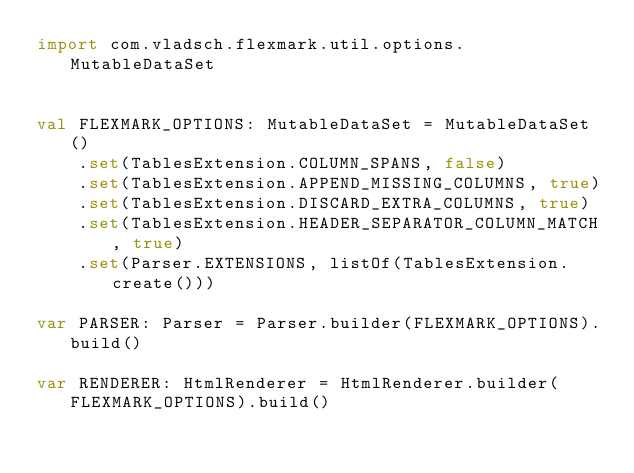Convert code to text. <code><loc_0><loc_0><loc_500><loc_500><_Kotlin_>import com.vladsch.flexmark.util.options.MutableDataSet


val FLEXMARK_OPTIONS: MutableDataSet = MutableDataSet()
    .set(TablesExtension.COLUMN_SPANS, false)
    .set(TablesExtension.APPEND_MISSING_COLUMNS, true)
    .set(TablesExtension.DISCARD_EXTRA_COLUMNS, true)
    .set(TablesExtension.HEADER_SEPARATOR_COLUMN_MATCH, true)
    .set(Parser.EXTENSIONS, listOf(TablesExtension.create()))

var PARSER: Parser = Parser.builder(FLEXMARK_OPTIONS).build()

var RENDERER: HtmlRenderer = HtmlRenderer.builder(FLEXMARK_OPTIONS).build()</code> 